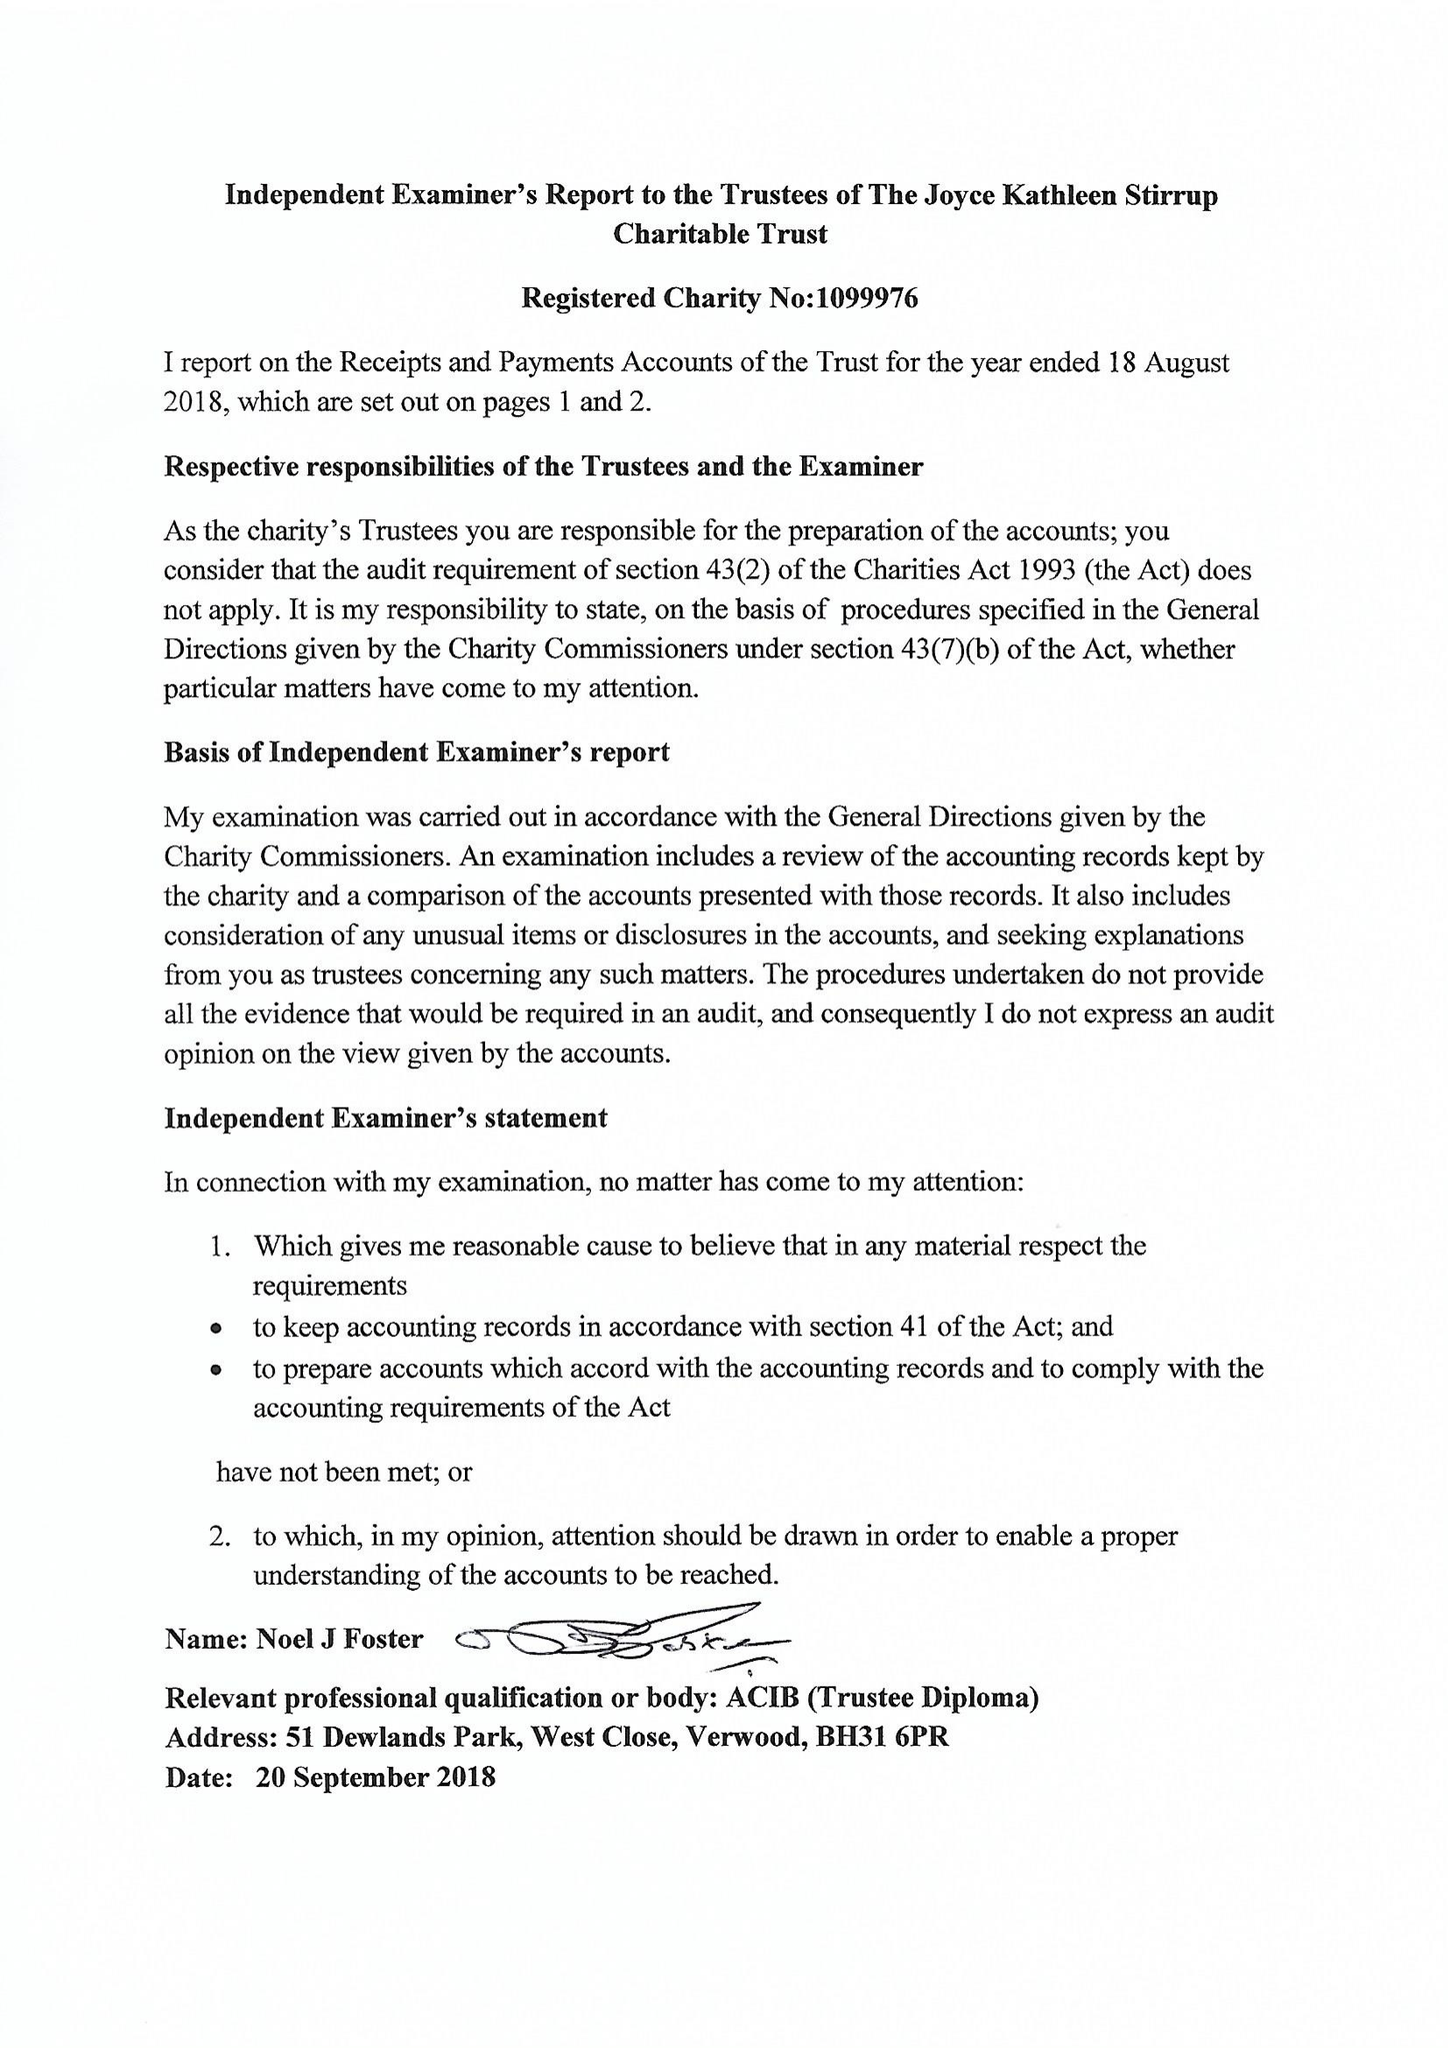What is the value for the address__postcode?
Answer the question using a single word or phrase. BS2 0PT 